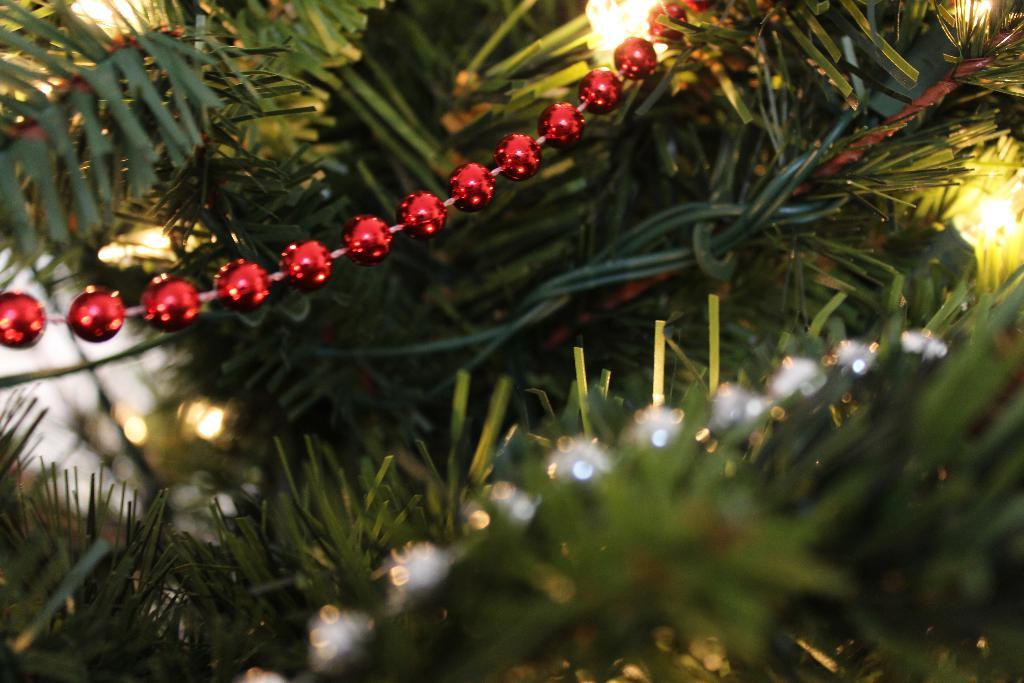What type of living organisms can be seen in the image? Plants can be seen in the image. How many decorative items are present in the image? There are two decorative items in the image. What colors are the decorative items? The decorative items are in red and white colors. Where is the match located in the image? There is no match present in the image. What type of furniture is the throne in the image? There is no throne present in the image. 